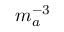Convert formula to latex. <formula><loc_0><loc_0><loc_500><loc_500>m _ { a } ^ { - 3 }</formula> 